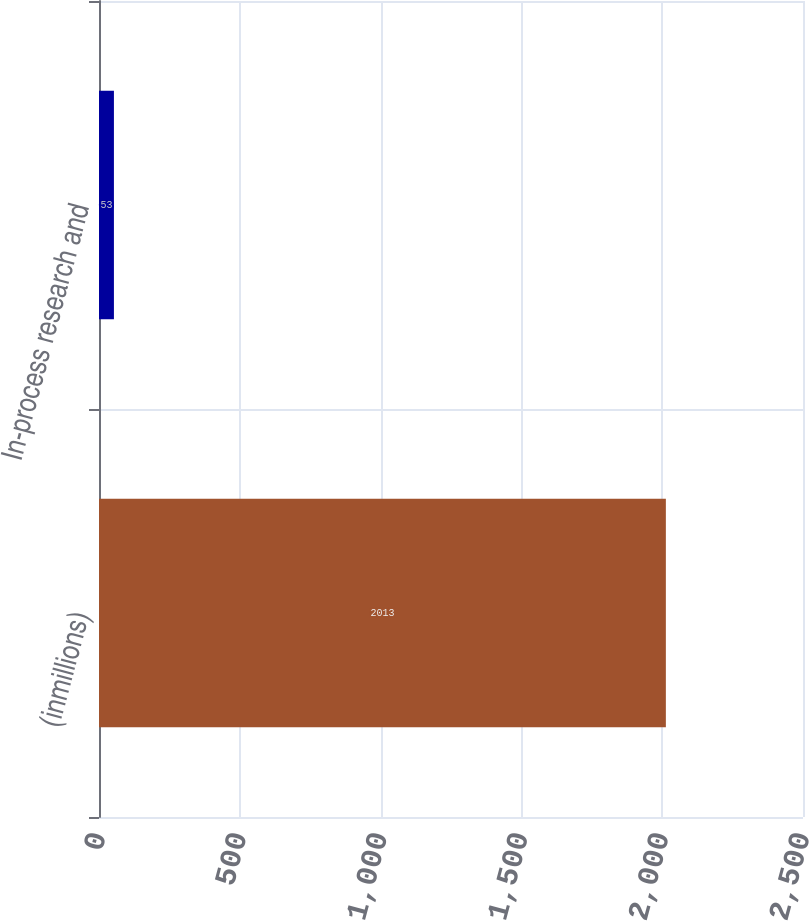<chart> <loc_0><loc_0><loc_500><loc_500><bar_chart><fcel>(inmillions)<fcel>In-process research and<nl><fcel>2013<fcel>53<nl></chart> 